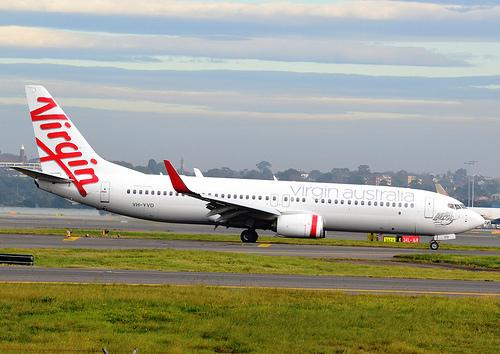Mention three distinct elements observed in the sky and on the ground. Lines of clouds in the sky, runway the plane is stopped on, and grass in front of the airplane. What type of plane is it and what is written on its side? It's a Virgin Australia passenger jet plane with "Virgin Australia" written on the side and code "vhyyd". What is the airplane doing and where is it located? The airplane is stopped on the runway, presumably at an airport, with trees and buildings in the background. Mention the primary object in the image and its most noticeable features. A white and red airplane with Virgin Australia branding, stopped on the runway, has windows on the cockpit, two doors, and a red upturned tip on the wing.  Provide a brief description of the plane's wing and landing gear. The airplane wing has a red upturned tip and a jet engine underneath, while the front and rear landing gear consist of tires and wheels. Describe any notable features on the airplane's tail. The tail wing has the Virgin Airline logo and the tail fin is white with red accents. What can you see at the airport besides the plane? Yellow and orange signs, trees and buildings, poles in the background, runway, and grass in front of the airplane. Briefly describe the airplane as well as its surroundings. A white and red Virgin Australia passenger jet is stopped on the runway, with grass in the front, trees, buildings, and poles in the background. List key components and markings on the airplane. Windows on the cockpit, two doors, red upturned tip on the wing, wheels, nose, line of windows, wing, tires, tail wing, and code "vhyyd" written on the side. Describe the colors, text and logo present on the plane. The plane is white and red with "Virgin Australia" written on its side, featuring the Virgin Airline logo on the tail of the passenger jet plane. 